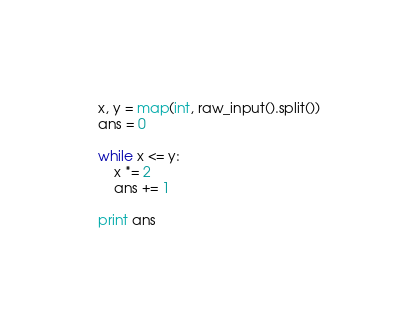<code> <loc_0><loc_0><loc_500><loc_500><_Python_>x, y = map(int, raw_input().split())
ans = 0

while x <= y:
    x *= 2
    ans += 1

print ans
</code> 